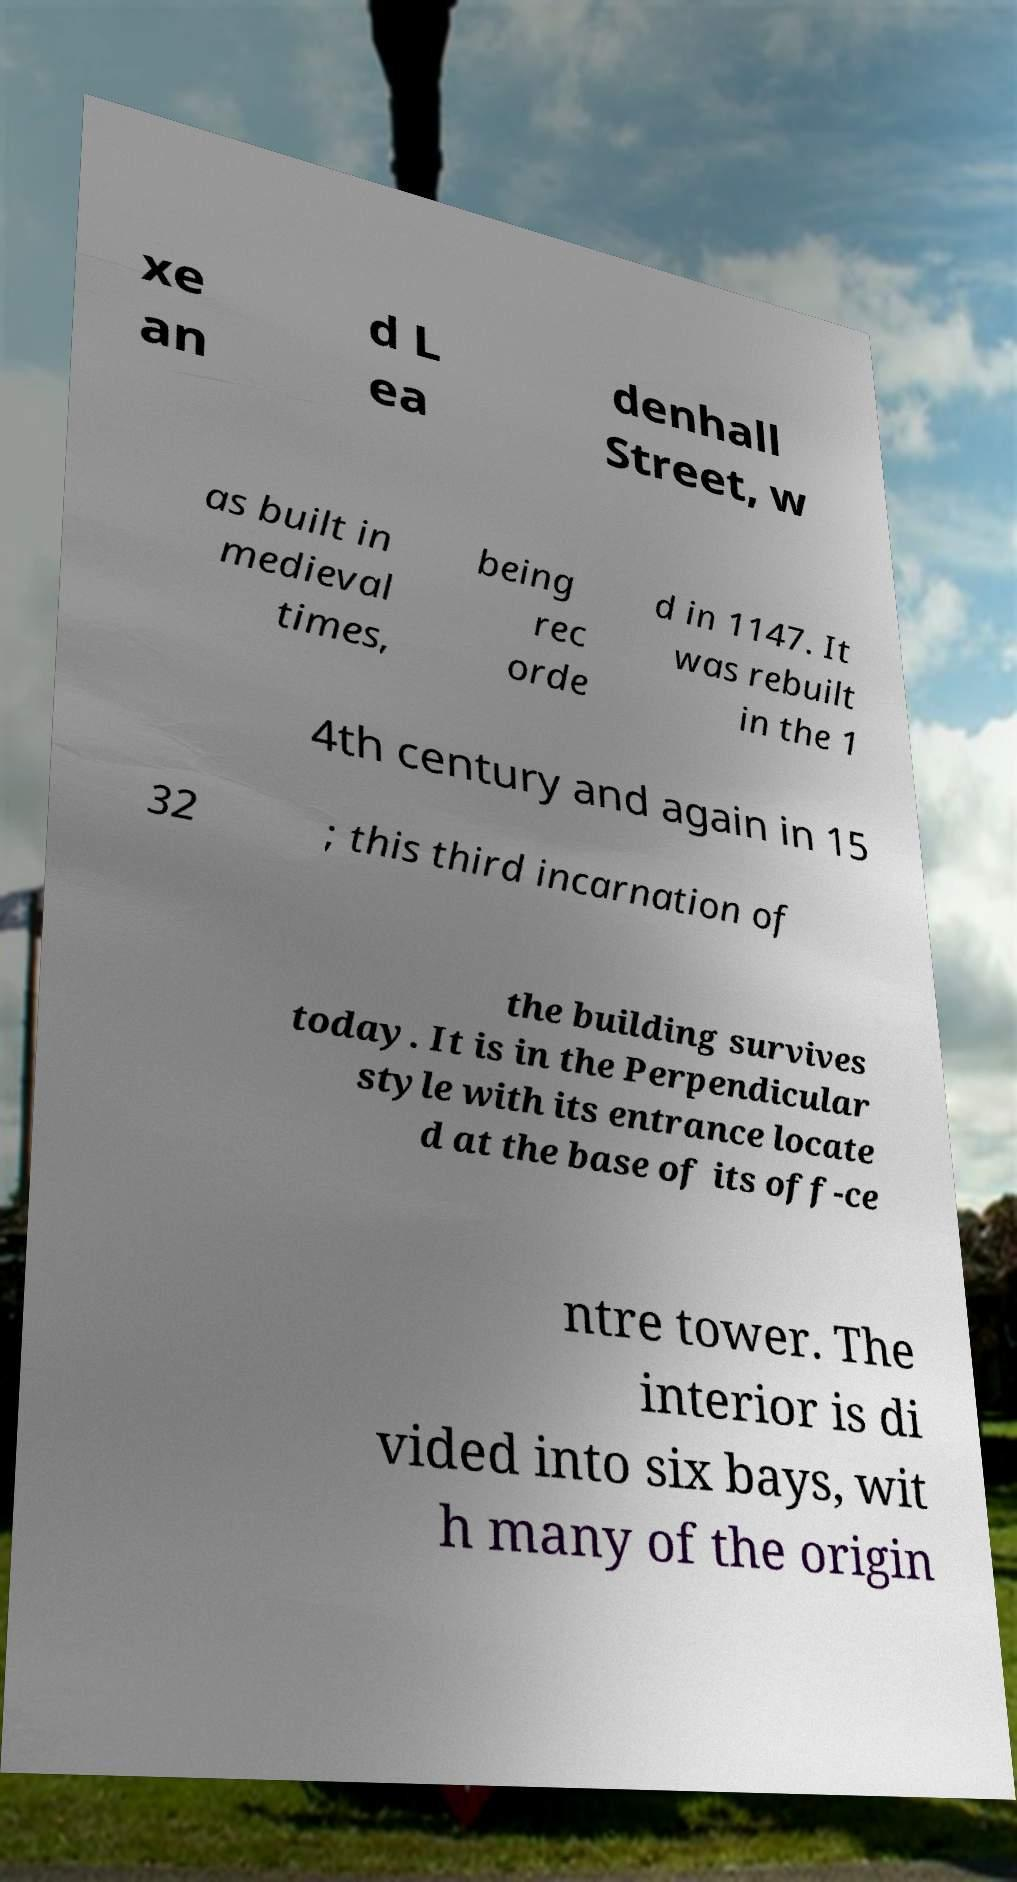For documentation purposes, I need the text within this image transcribed. Could you provide that? xe an d L ea denhall Street, w as built in medieval times, being rec orde d in 1147. It was rebuilt in the 1 4th century and again in 15 32 ; this third incarnation of the building survives today. It is in the Perpendicular style with its entrance locate d at the base of its off-ce ntre tower. The interior is di vided into six bays, wit h many of the origin 